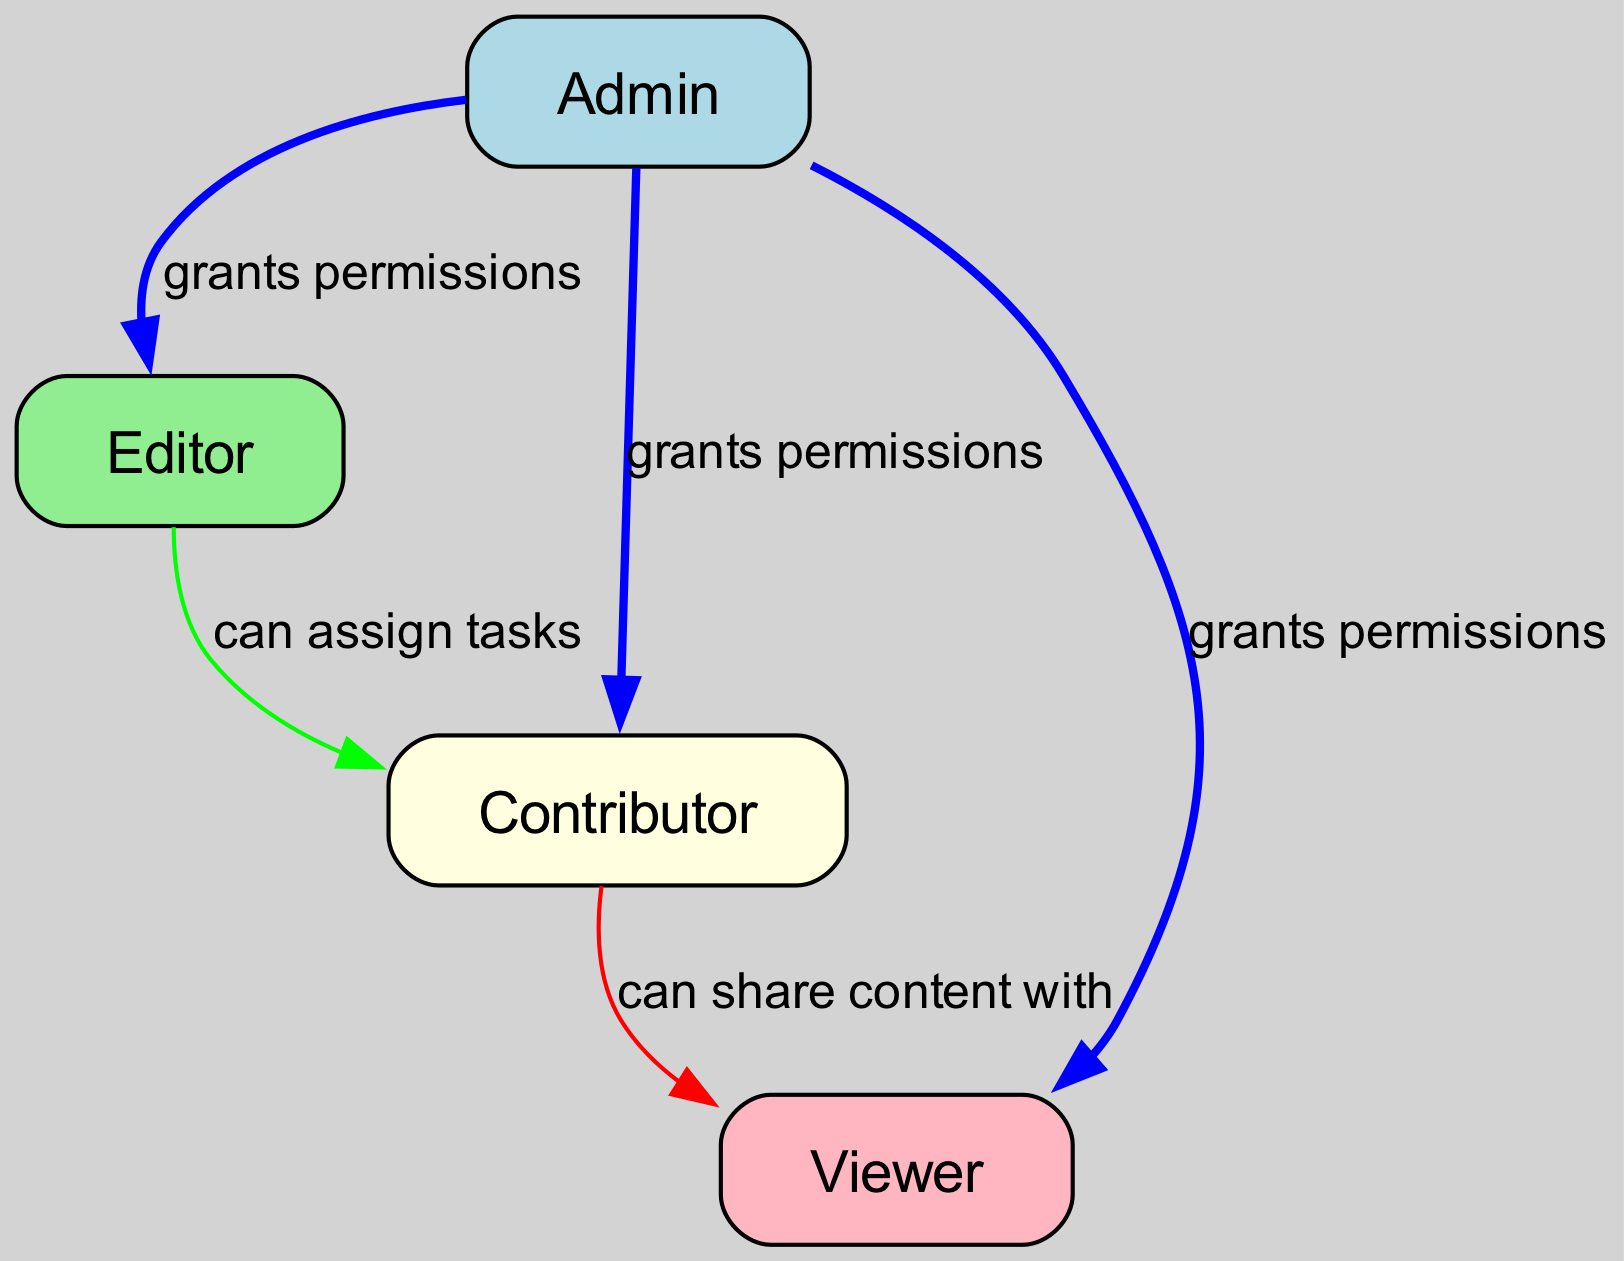What are the different user roles in the diagram? The diagram shows four user roles: Admin, Editor, Contributor, and Viewer. These are identified as distinct nodes in the directed graph.
Answer: Admin, Editor, Contributor, Viewer How many edges are present in the diagram? By counting the connections (edges) between the nodes, we find there are five edges indicating the relationships between different user roles.
Answer: 5 Which role can assign tasks to the Contributor? The edge from Editor to Contributor, labeled "can assign tasks," indicates that the Editor has the capability to assign tasks specifically to the Contributor.
Answer: Editor What relationship does the Admin have with the Viewer? The diagram shows a directed edge from Admin to Viewer with the label "grants permissions," signifying that the Admin grants permissions to the Viewer.
Answer: grants permissions Which user role can share content with the Viewer? The directed edge from Contributor to Viewer is labeled "can share content with," indicating that the Contributor has the ability to share content specifically with the Viewer.
Answer: Contributor Which user role has the most permissions in the diagram? The Admin role has directed edges to all other roles (Editor, Contributor, Viewer), indicating it grants permissions across the board, thus having the most permissions.
Answer: Admin How many user roles can be assigned tasks? Based on the diagram, only the Editor can assign tasks to the Contributor, so there is one user role that can assign tasks.
Answer: 1 What is the color used for the Contributor node in the diagram? In the graphical representation, the Contributor node is filled with a light yellow color, differentiating it from other roles.
Answer: light yellow 